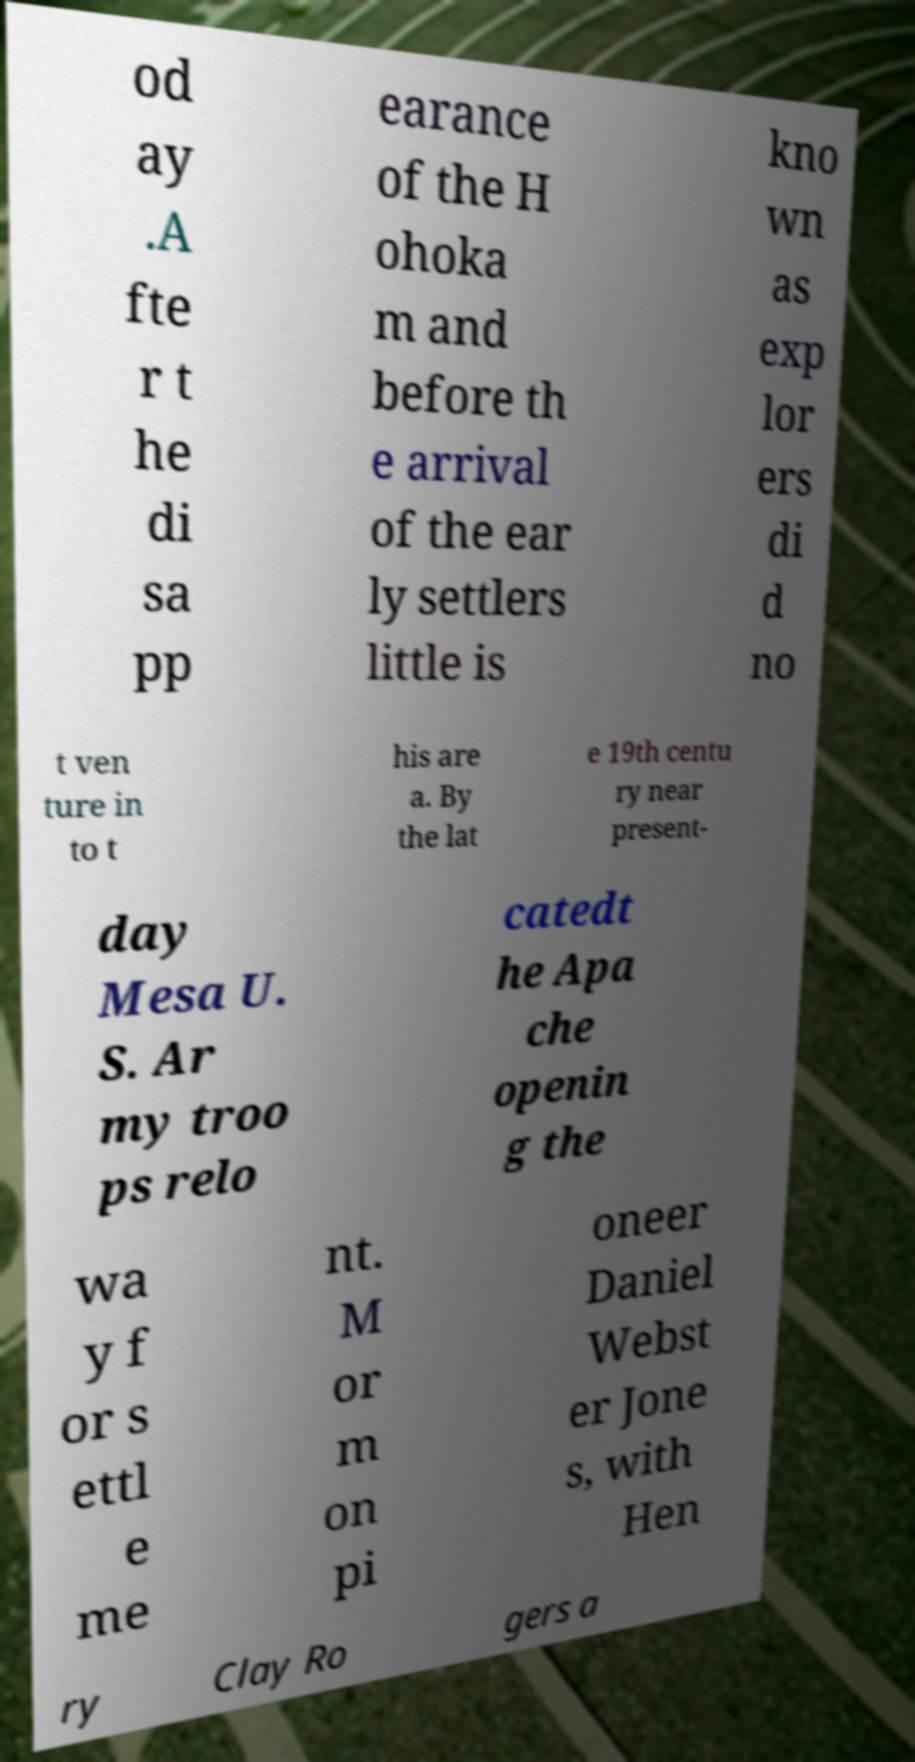For documentation purposes, I need the text within this image transcribed. Could you provide that? od ay .A fte r t he di sa pp earance of the H ohoka m and before th e arrival of the ear ly settlers little is kno wn as exp lor ers di d no t ven ture in to t his are a. By the lat e 19th centu ry near present- day Mesa U. S. Ar my troo ps relo catedt he Apa che openin g the wa y f or s ettl e me nt. M or m on pi oneer Daniel Webst er Jone s, with Hen ry Clay Ro gers a 